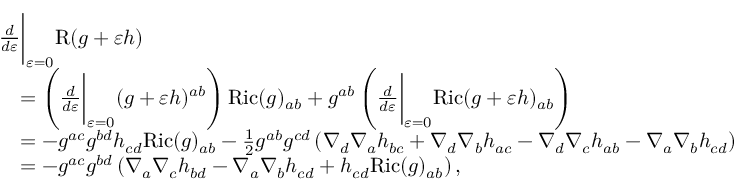Convert formula to latex. <formula><loc_0><loc_0><loc_500><loc_500>\begin{array} { r l } & { \frac { d } { d \varepsilon } \Big | _ { \varepsilon = 0 } R ( g + \varepsilon h ) } \\ & { \quad = \left ( \frac { d } { d \varepsilon } \Big | _ { \varepsilon = 0 } ( g + \varepsilon h ) ^ { a b } \right ) R i c ( g ) _ { a b } + g ^ { a b } \left ( \frac { d } { d \varepsilon } \Big | _ { \varepsilon = 0 } R i c ( g + \varepsilon h ) _ { a b } \right ) } \\ & { \quad = - g ^ { a c } g ^ { b d } h _ { c d } R i c ( g ) _ { a b } - \frac { 1 } { 2 } g ^ { a b } g ^ { c d } \left ( \nabla _ { d } \nabla _ { a } h _ { b c } + \nabla _ { d } \nabla _ { b } h _ { a c } - \nabla _ { d } \nabla _ { c } h _ { a b } - \nabla _ { a } \nabla _ { b } h _ { c d } \right ) } \\ & { \quad = - g ^ { a c } g ^ { b d } \left ( \nabla _ { a } \nabla _ { c } h _ { b d } - \nabla _ { a } \nabla _ { b } h _ { c d } + h _ { c d } R i c ( g ) _ { a b } \right ) , } \end{array}</formula> 